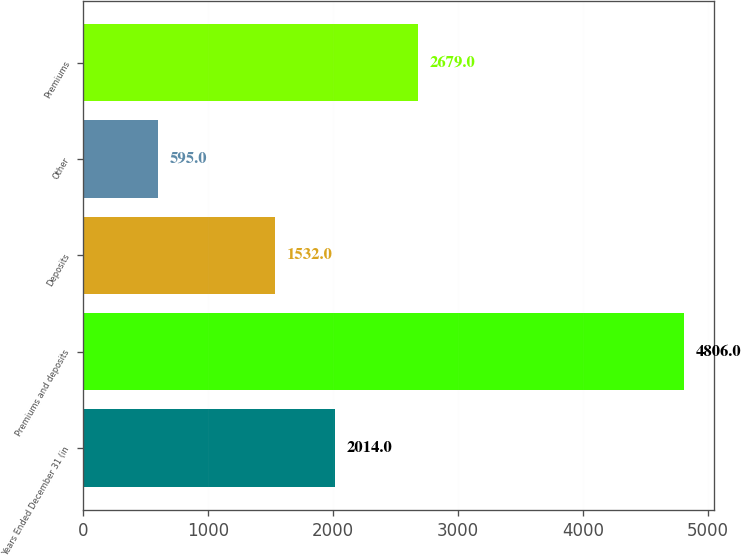<chart> <loc_0><loc_0><loc_500><loc_500><bar_chart><fcel>Years Ended December 31 (in<fcel>Premiums and deposits<fcel>Deposits<fcel>Other<fcel>Premiums<nl><fcel>2014<fcel>4806<fcel>1532<fcel>595<fcel>2679<nl></chart> 